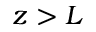<formula> <loc_0><loc_0><loc_500><loc_500>z > L</formula> 